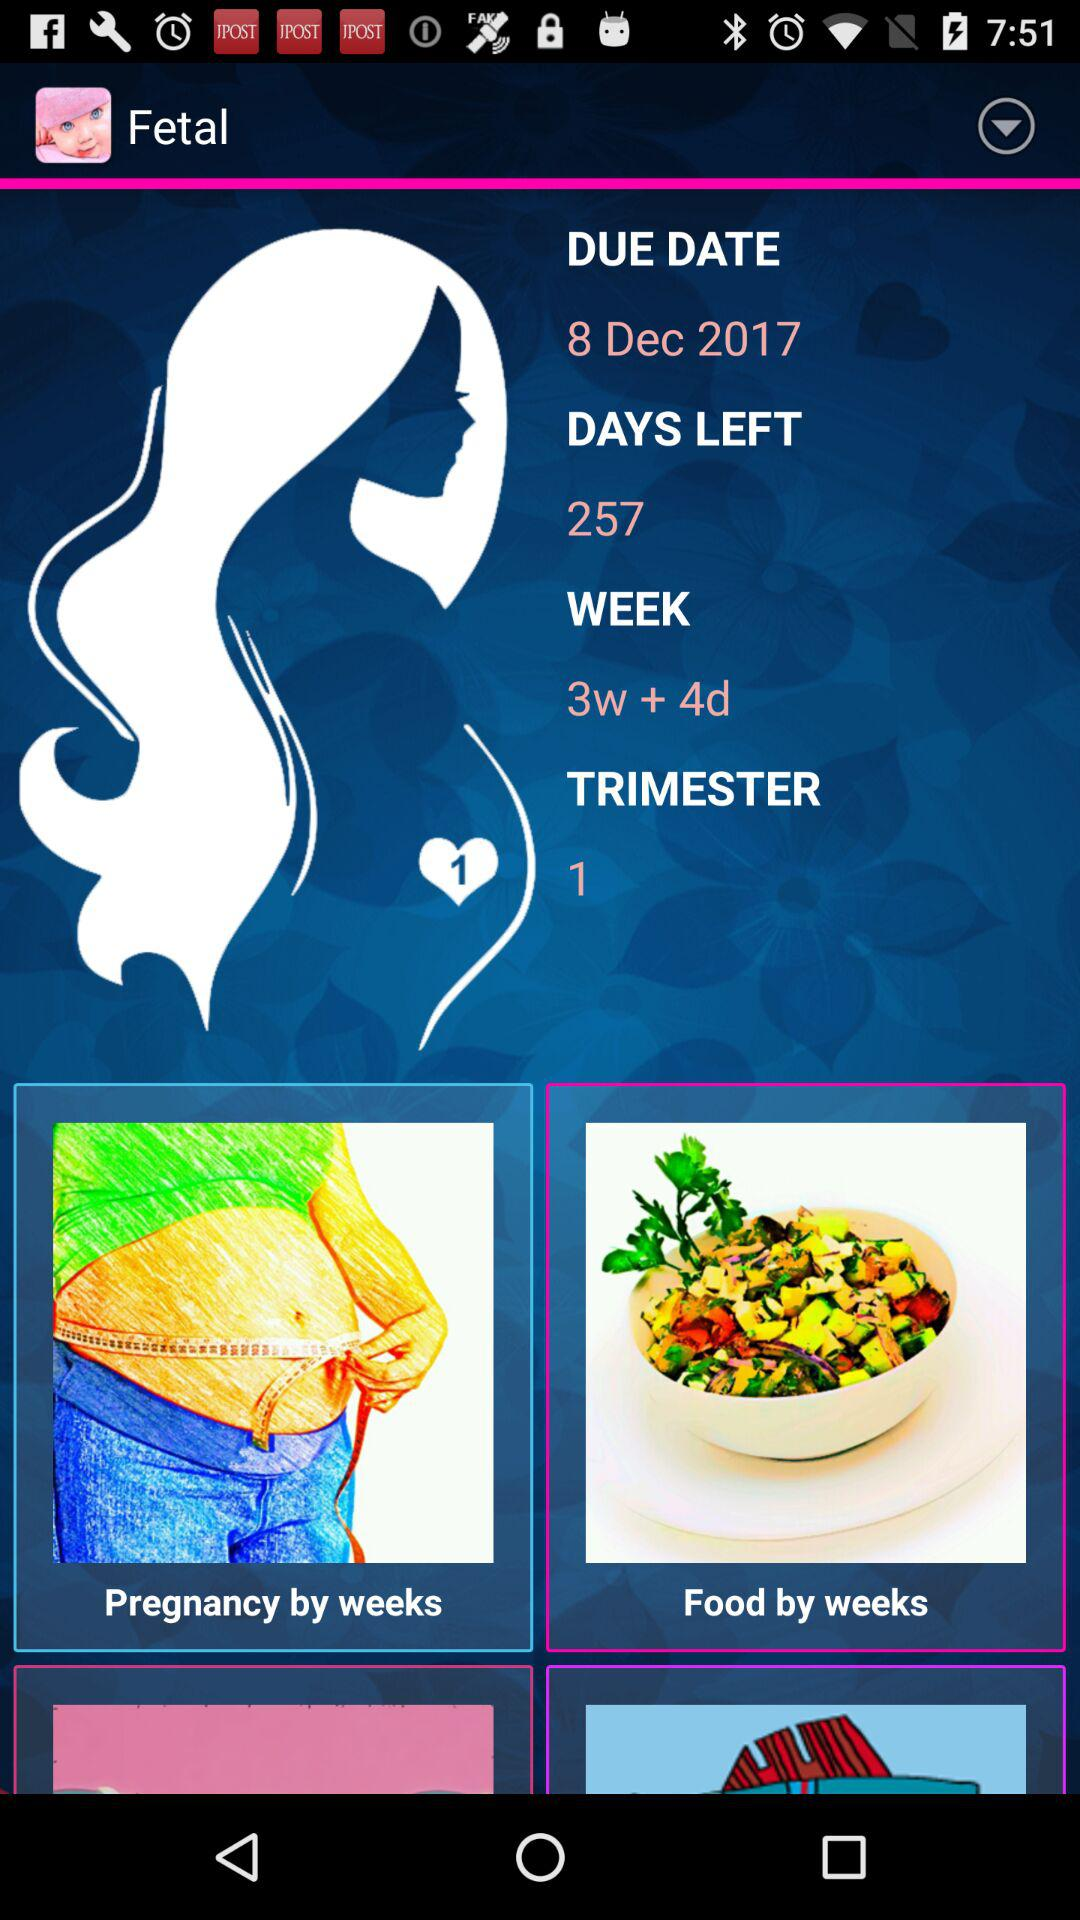What is the current trimester? The current trimester is 1. 